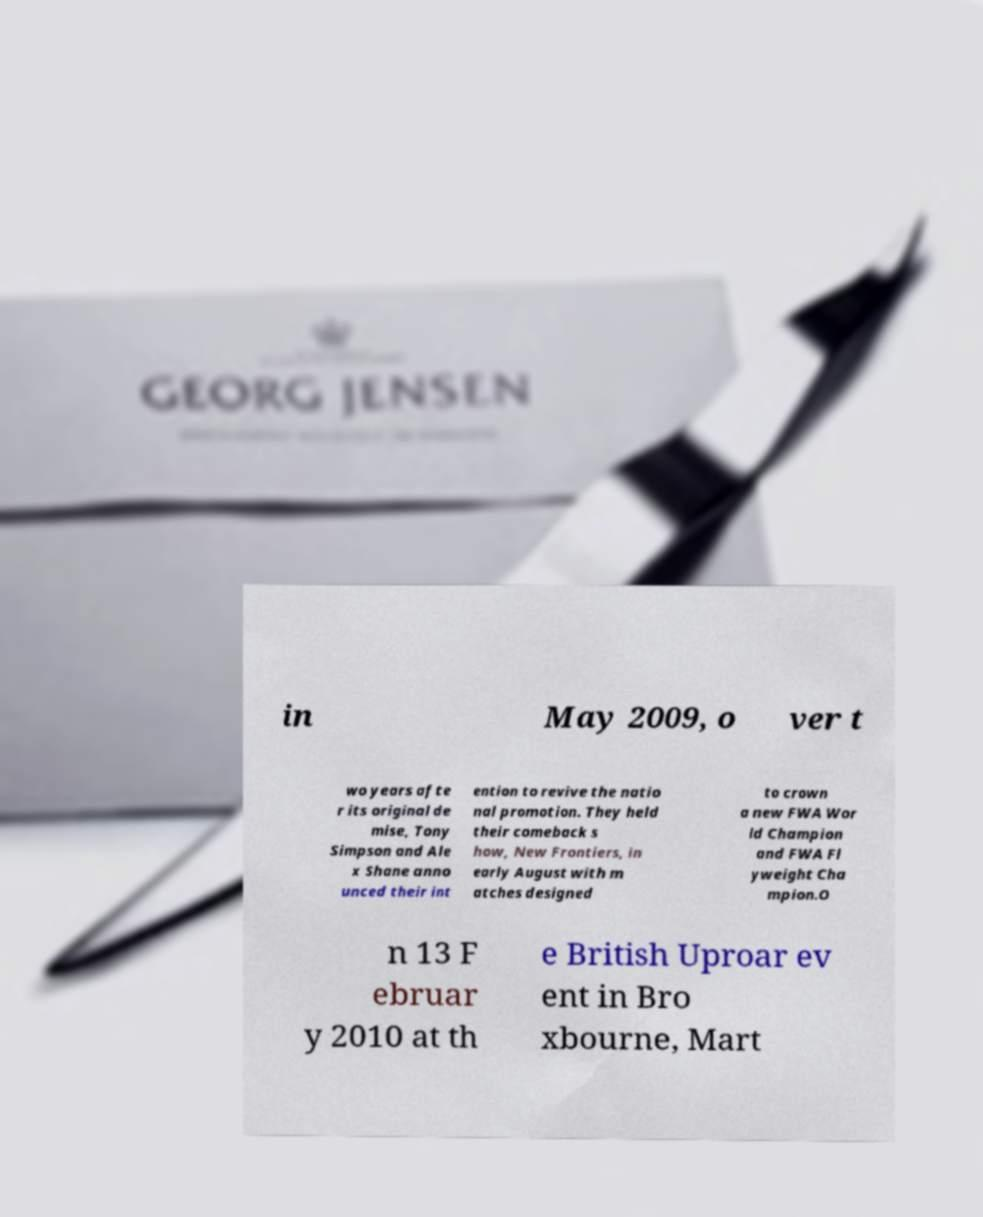Could you assist in decoding the text presented in this image and type it out clearly? in May 2009, o ver t wo years afte r its original de mise, Tony Simpson and Ale x Shane anno unced their int ention to revive the natio nal promotion. They held their comeback s how, New Frontiers, in early August with m atches designed to crown a new FWA Wor ld Champion and FWA Fl yweight Cha mpion.O n 13 F ebruar y 2010 at th e British Uproar ev ent in Bro xbourne, Mart 